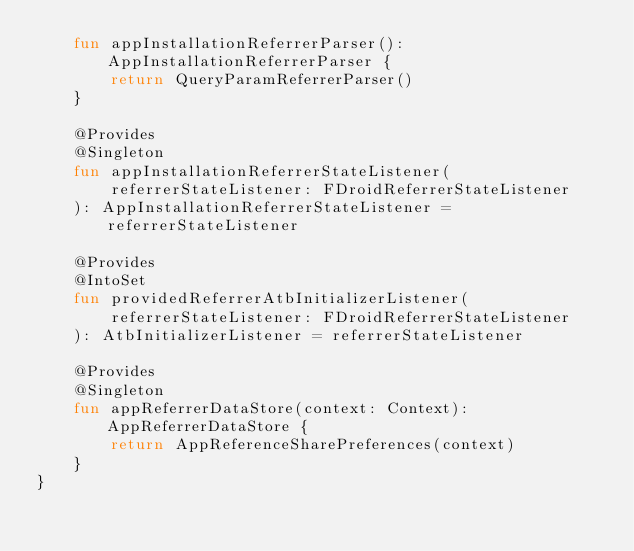<code> <loc_0><loc_0><loc_500><loc_500><_Kotlin_>    fun appInstallationReferrerParser(): AppInstallationReferrerParser {
        return QueryParamReferrerParser()
    }

    @Provides
    @Singleton
    fun appInstallationReferrerStateListener(
        referrerStateListener: FDroidReferrerStateListener
    ): AppInstallationReferrerStateListener = referrerStateListener

    @Provides
    @IntoSet
    fun providedReferrerAtbInitializerListener(
        referrerStateListener: FDroidReferrerStateListener
    ): AtbInitializerListener = referrerStateListener

    @Provides
    @Singleton
    fun appReferrerDataStore(context: Context): AppReferrerDataStore {
        return AppReferenceSharePreferences(context)
    }
}
</code> 